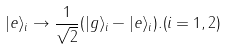<formula> <loc_0><loc_0><loc_500><loc_500>| e \rangle _ { i } \rightarrow \frac { 1 } { \sqrt { 2 } } ( | g \rangle _ { i } - | e \rangle _ { i } ) . ( i = 1 , 2 )</formula> 